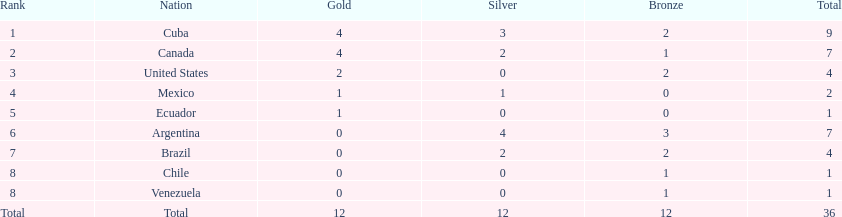Which is the only nation to win a gold medal and nothing else? Ecuador. 